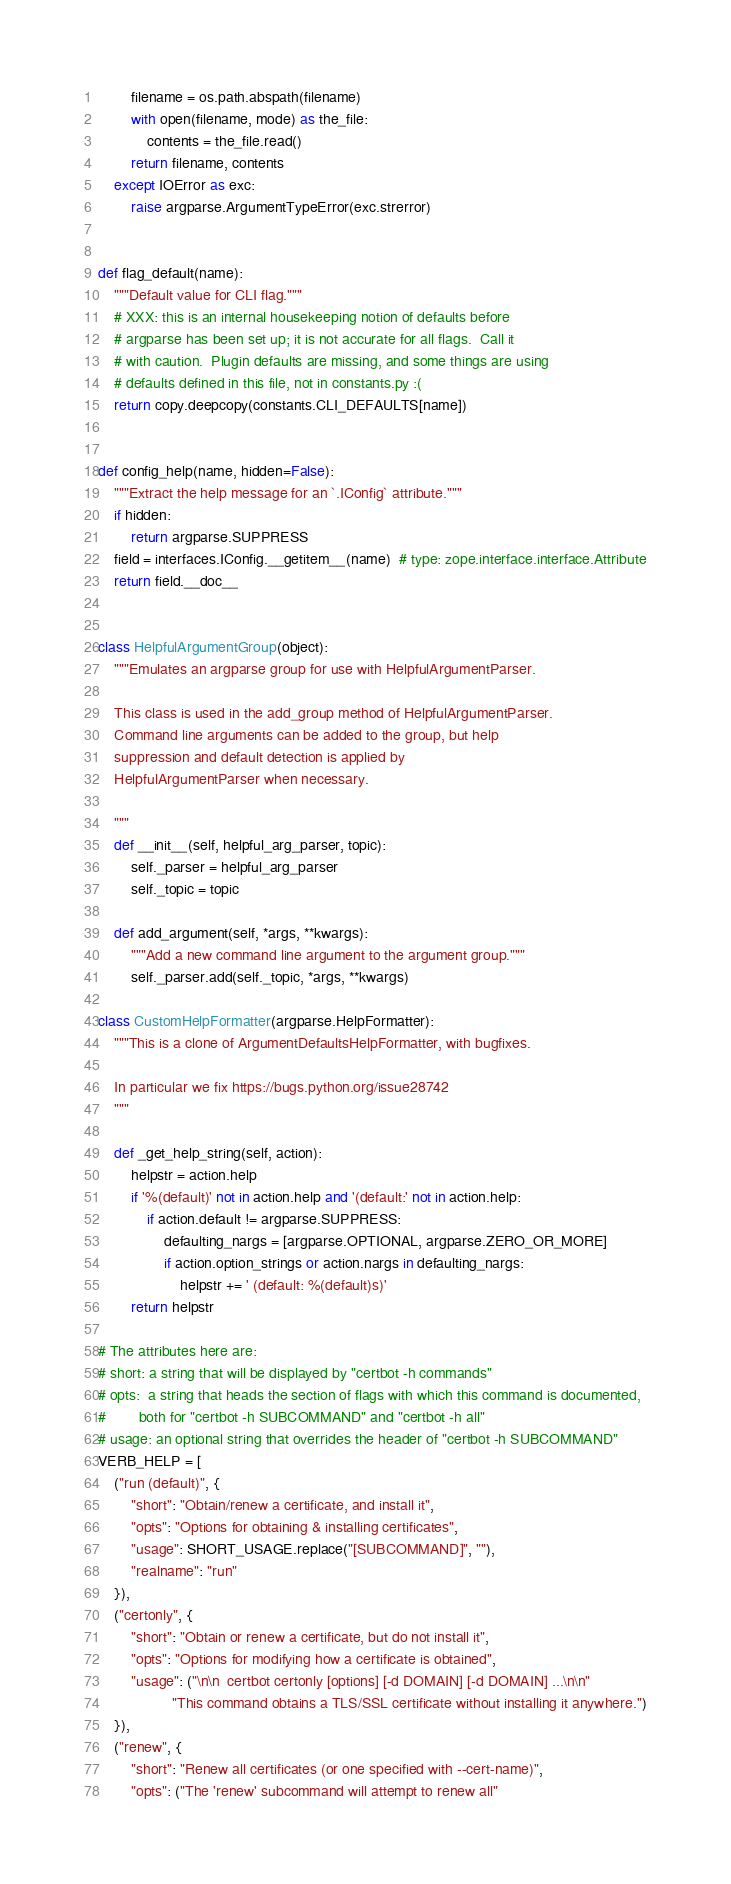Convert code to text. <code><loc_0><loc_0><loc_500><loc_500><_Python_>        filename = os.path.abspath(filename)
        with open(filename, mode) as the_file:
            contents = the_file.read()
        return filename, contents
    except IOError as exc:
        raise argparse.ArgumentTypeError(exc.strerror)


def flag_default(name):
    """Default value for CLI flag."""
    # XXX: this is an internal housekeeping notion of defaults before
    # argparse has been set up; it is not accurate for all flags.  Call it
    # with caution.  Plugin defaults are missing, and some things are using
    # defaults defined in this file, not in constants.py :(
    return copy.deepcopy(constants.CLI_DEFAULTS[name])


def config_help(name, hidden=False):
    """Extract the help message for an `.IConfig` attribute."""
    if hidden:
        return argparse.SUPPRESS
    field = interfaces.IConfig.__getitem__(name)  # type: zope.interface.interface.Attribute
    return field.__doc__


class HelpfulArgumentGroup(object):
    """Emulates an argparse group for use with HelpfulArgumentParser.

    This class is used in the add_group method of HelpfulArgumentParser.
    Command line arguments can be added to the group, but help
    suppression and default detection is applied by
    HelpfulArgumentParser when necessary.

    """
    def __init__(self, helpful_arg_parser, topic):
        self._parser = helpful_arg_parser
        self._topic = topic

    def add_argument(self, *args, **kwargs):
        """Add a new command line argument to the argument group."""
        self._parser.add(self._topic, *args, **kwargs)

class CustomHelpFormatter(argparse.HelpFormatter):
    """This is a clone of ArgumentDefaultsHelpFormatter, with bugfixes.

    In particular we fix https://bugs.python.org/issue28742
    """

    def _get_help_string(self, action):
        helpstr = action.help
        if '%(default)' not in action.help and '(default:' not in action.help:
            if action.default != argparse.SUPPRESS:
                defaulting_nargs = [argparse.OPTIONAL, argparse.ZERO_OR_MORE]
                if action.option_strings or action.nargs in defaulting_nargs:
                    helpstr += ' (default: %(default)s)'
        return helpstr

# The attributes here are:
# short: a string that will be displayed by "certbot -h commands"
# opts:  a string that heads the section of flags with which this command is documented,
#        both for "certbot -h SUBCOMMAND" and "certbot -h all"
# usage: an optional string that overrides the header of "certbot -h SUBCOMMAND"
VERB_HELP = [
    ("run (default)", {
        "short": "Obtain/renew a certificate, and install it",
        "opts": "Options for obtaining & installing certificates",
        "usage": SHORT_USAGE.replace("[SUBCOMMAND]", ""),
        "realname": "run"
    }),
    ("certonly", {
        "short": "Obtain or renew a certificate, but do not install it",
        "opts": "Options for modifying how a certificate is obtained",
        "usage": ("\n\n  certbot certonly [options] [-d DOMAIN] [-d DOMAIN] ...\n\n"
                  "This command obtains a TLS/SSL certificate without installing it anywhere.")
    }),
    ("renew", {
        "short": "Renew all certificates (or one specified with --cert-name)",
        "opts": ("The 'renew' subcommand will attempt to renew all"</code> 